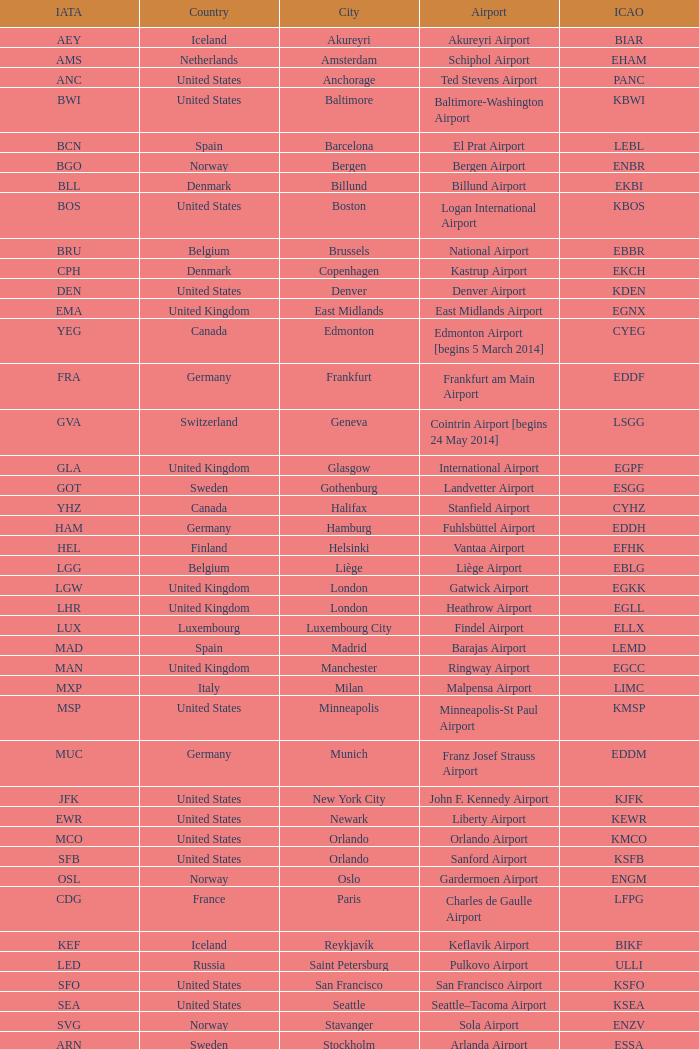What is the Airport with a ICAO of EDDH? Fuhlsbüttel Airport. 